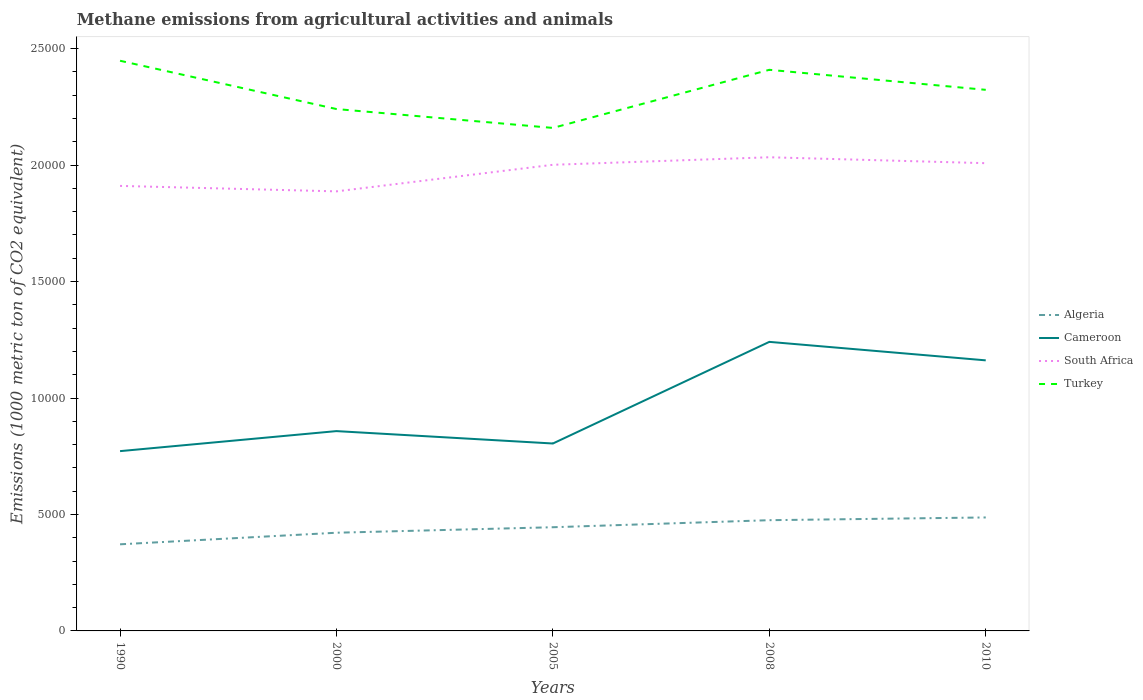Across all years, what is the maximum amount of methane emitted in Cameroon?
Provide a succinct answer. 7719.8. What is the total amount of methane emitted in Algeria in the graph?
Make the answer very short. -302.6. What is the difference between the highest and the second highest amount of methane emitted in Cameroon?
Provide a short and direct response. 4691.5. What is the difference between the highest and the lowest amount of methane emitted in Cameroon?
Offer a very short reply. 2. What is the difference between two consecutive major ticks on the Y-axis?
Give a very brief answer. 5000. Are the values on the major ticks of Y-axis written in scientific E-notation?
Offer a very short reply. No. Does the graph contain grids?
Provide a short and direct response. No. Where does the legend appear in the graph?
Offer a very short reply. Center right. How are the legend labels stacked?
Give a very brief answer. Vertical. What is the title of the graph?
Give a very brief answer. Methane emissions from agricultural activities and animals. Does "Djibouti" appear as one of the legend labels in the graph?
Your answer should be compact. No. What is the label or title of the Y-axis?
Make the answer very short. Emissions (1000 metric ton of CO2 equivalent). What is the Emissions (1000 metric ton of CO2 equivalent) in Algeria in 1990?
Offer a very short reply. 3718.9. What is the Emissions (1000 metric ton of CO2 equivalent) of Cameroon in 1990?
Provide a succinct answer. 7719.8. What is the Emissions (1000 metric ton of CO2 equivalent) in South Africa in 1990?
Provide a short and direct response. 1.91e+04. What is the Emissions (1000 metric ton of CO2 equivalent) in Turkey in 1990?
Your answer should be very brief. 2.45e+04. What is the Emissions (1000 metric ton of CO2 equivalent) in Algeria in 2000?
Ensure brevity in your answer.  4216.3. What is the Emissions (1000 metric ton of CO2 equivalent) of Cameroon in 2000?
Make the answer very short. 8579.6. What is the Emissions (1000 metric ton of CO2 equivalent) in South Africa in 2000?
Provide a succinct answer. 1.89e+04. What is the Emissions (1000 metric ton of CO2 equivalent) of Turkey in 2000?
Make the answer very short. 2.24e+04. What is the Emissions (1000 metric ton of CO2 equivalent) of Algeria in 2005?
Your answer should be very brief. 4452.1. What is the Emissions (1000 metric ton of CO2 equivalent) of Cameroon in 2005?
Provide a succinct answer. 8047.3. What is the Emissions (1000 metric ton of CO2 equivalent) of South Africa in 2005?
Your answer should be very brief. 2.00e+04. What is the Emissions (1000 metric ton of CO2 equivalent) of Turkey in 2005?
Your answer should be very brief. 2.16e+04. What is the Emissions (1000 metric ton of CO2 equivalent) in Algeria in 2008?
Keep it short and to the point. 4754.7. What is the Emissions (1000 metric ton of CO2 equivalent) of Cameroon in 2008?
Your answer should be compact. 1.24e+04. What is the Emissions (1000 metric ton of CO2 equivalent) of South Africa in 2008?
Offer a very short reply. 2.03e+04. What is the Emissions (1000 metric ton of CO2 equivalent) in Turkey in 2008?
Ensure brevity in your answer.  2.41e+04. What is the Emissions (1000 metric ton of CO2 equivalent) of Algeria in 2010?
Keep it short and to the point. 4872.2. What is the Emissions (1000 metric ton of CO2 equivalent) in Cameroon in 2010?
Provide a succinct answer. 1.16e+04. What is the Emissions (1000 metric ton of CO2 equivalent) of South Africa in 2010?
Ensure brevity in your answer.  2.01e+04. What is the Emissions (1000 metric ton of CO2 equivalent) in Turkey in 2010?
Give a very brief answer. 2.32e+04. Across all years, what is the maximum Emissions (1000 metric ton of CO2 equivalent) of Algeria?
Your answer should be very brief. 4872.2. Across all years, what is the maximum Emissions (1000 metric ton of CO2 equivalent) in Cameroon?
Ensure brevity in your answer.  1.24e+04. Across all years, what is the maximum Emissions (1000 metric ton of CO2 equivalent) in South Africa?
Ensure brevity in your answer.  2.03e+04. Across all years, what is the maximum Emissions (1000 metric ton of CO2 equivalent) in Turkey?
Your answer should be very brief. 2.45e+04. Across all years, what is the minimum Emissions (1000 metric ton of CO2 equivalent) of Algeria?
Ensure brevity in your answer.  3718.9. Across all years, what is the minimum Emissions (1000 metric ton of CO2 equivalent) of Cameroon?
Your answer should be compact. 7719.8. Across all years, what is the minimum Emissions (1000 metric ton of CO2 equivalent) in South Africa?
Make the answer very short. 1.89e+04. Across all years, what is the minimum Emissions (1000 metric ton of CO2 equivalent) in Turkey?
Your answer should be very brief. 2.16e+04. What is the total Emissions (1000 metric ton of CO2 equivalent) of Algeria in the graph?
Provide a short and direct response. 2.20e+04. What is the total Emissions (1000 metric ton of CO2 equivalent) of Cameroon in the graph?
Provide a succinct answer. 4.84e+04. What is the total Emissions (1000 metric ton of CO2 equivalent) in South Africa in the graph?
Provide a succinct answer. 9.84e+04. What is the total Emissions (1000 metric ton of CO2 equivalent) of Turkey in the graph?
Offer a very short reply. 1.16e+05. What is the difference between the Emissions (1000 metric ton of CO2 equivalent) in Algeria in 1990 and that in 2000?
Your answer should be very brief. -497.4. What is the difference between the Emissions (1000 metric ton of CO2 equivalent) in Cameroon in 1990 and that in 2000?
Provide a short and direct response. -859.8. What is the difference between the Emissions (1000 metric ton of CO2 equivalent) in South Africa in 1990 and that in 2000?
Make the answer very short. 234.6. What is the difference between the Emissions (1000 metric ton of CO2 equivalent) of Turkey in 1990 and that in 2000?
Your answer should be compact. 2073.6. What is the difference between the Emissions (1000 metric ton of CO2 equivalent) of Algeria in 1990 and that in 2005?
Provide a succinct answer. -733.2. What is the difference between the Emissions (1000 metric ton of CO2 equivalent) in Cameroon in 1990 and that in 2005?
Provide a succinct answer. -327.5. What is the difference between the Emissions (1000 metric ton of CO2 equivalent) in South Africa in 1990 and that in 2005?
Keep it short and to the point. -906.3. What is the difference between the Emissions (1000 metric ton of CO2 equivalent) of Turkey in 1990 and that in 2005?
Keep it short and to the point. 2884.1. What is the difference between the Emissions (1000 metric ton of CO2 equivalent) in Algeria in 1990 and that in 2008?
Your response must be concise. -1035.8. What is the difference between the Emissions (1000 metric ton of CO2 equivalent) in Cameroon in 1990 and that in 2008?
Make the answer very short. -4691.5. What is the difference between the Emissions (1000 metric ton of CO2 equivalent) in South Africa in 1990 and that in 2008?
Your answer should be very brief. -1229.7. What is the difference between the Emissions (1000 metric ton of CO2 equivalent) in Turkey in 1990 and that in 2008?
Your answer should be compact. 388.8. What is the difference between the Emissions (1000 metric ton of CO2 equivalent) in Algeria in 1990 and that in 2010?
Offer a very short reply. -1153.3. What is the difference between the Emissions (1000 metric ton of CO2 equivalent) in Cameroon in 1990 and that in 2010?
Offer a very short reply. -3897.7. What is the difference between the Emissions (1000 metric ton of CO2 equivalent) in South Africa in 1990 and that in 2010?
Keep it short and to the point. -975.4. What is the difference between the Emissions (1000 metric ton of CO2 equivalent) of Turkey in 1990 and that in 2010?
Make the answer very short. 1248.6. What is the difference between the Emissions (1000 metric ton of CO2 equivalent) of Algeria in 2000 and that in 2005?
Offer a very short reply. -235.8. What is the difference between the Emissions (1000 metric ton of CO2 equivalent) in Cameroon in 2000 and that in 2005?
Provide a succinct answer. 532.3. What is the difference between the Emissions (1000 metric ton of CO2 equivalent) of South Africa in 2000 and that in 2005?
Provide a short and direct response. -1140.9. What is the difference between the Emissions (1000 metric ton of CO2 equivalent) in Turkey in 2000 and that in 2005?
Your answer should be compact. 810.5. What is the difference between the Emissions (1000 metric ton of CO2 equivalent) in Algeria in 2000 and that in 2008?
Your answer should be compact. -538.4. What is the difference between the Emissions (1000 metric ton of CO2 equivalent) in Cameroon in 2000 and that in 2008?
Make the answer very short. -3831.7. What is the difference between the Emissions (1000 metric ton of CO2 equivalent) of South Africa in 2000 and that in 2008?
Provide a short and direct response. -1464.3. What is the difference between the Emissions (1000 metric ton of CO2 equivalent) in Turkey in 2000 and that in 2008?
Keep it short and to the point. -1684.8. What is the difference between the Emissions (1000 metric ton of CO2 equivalent) of Algeria in 2000 and that in 2010?
Your answer should be compact. -655.9. What is the difference between the Emissions (1000 metric ton of CO2 equivalent) of Cameroon in 2000 and that in 2010?
Your answer should be very brief. -3037.9. What is the difference between the Emissions (1000 metric ton of CO2 equivalent) of South Africa in 2000 and that in 2010?
Offer a terse response. -1210. What is the difference between the Emissions (1000 metric ton of CO2 equivalent) of Turkey in 2000 and that in 2010?
Provide a short and direct response. -825. What is the difference between the Emissions (1000 metric ton of CO2 equivalent) in Algeria in 2005 and that in 2008?
Ensure brevity in your answer.  -302.6. What is the difference between the Emissions (1000 metric ton of CO2 equivalent) in Cameroon in 2005 and that in 2008?
Your response must be concise. -4364. What is the difference between the Emissions (1000 metric ton of CO2 equivalent) of South Africa in 2005 and that in 2008?
Your answer should be compact. -323.4. What is the difference between the Emissions (1000 metric ton of CO2 equivalent) of Turkey in 2005 and that in 2008?
Your response must be concise. -2495.3. What is the difference between the Emissions (1000 metric ton of CO2 equivalent) of Algeria in 2005 and that in 2010?
Your answer should be very brief. -420.1. What is the difference between the Emissions (1000 metric ton of CO2 equivalent) in Cameroon in 2005 and that in 2010?
Make the answer very short. -3570.2. What is the difference between the Emissions (1000 metric ton of CO2 equivalent) of South Africa in 2005 and that in 2010?
Give a very brief answer. -69.1. What is the difference between the Emissions (1000 metric ton of CO2 equivalent) of Turkey in 2005 and that in 2010?
Offer a very short reply. -1635.5. What is the difference between the Emissions (1000 metric ton of CO2 equivalent) of Algeria in 2008 and that in 2010?
Make the answer very short. -117.5. What is the difference between the Emissions (1000 metric ton of CO2 equivalent) in Cameroon in 2008 and that in 2010?
Your response must be concise. 793.8. What is the difference between the Emissions (1000 metric ton of CO2 equivalent) in South Africa in 2008 and that in 2010?
Give a very brief answer. 254.3. What is the difference between the Emissions (1000 metric ton of CO2 equivalent) of Turkey in 2008 and that in 2010?
Give a very brief answer. 859.8. What is the difference between the Emissions (1000 metric ton of CO2 equivalent) in Algeria in 1990 and the Emissions (1000 metric ton of CO2 equivalent) in Cameroon in 2000?
Provide a succinct answer. -4860.7. What is the difference between the Emissions (1000 metric ton of CO2 equivalent) in Algeria in 1990 and the Emissions (1000 metric ton of CO2 equivalent) in South Africa in 2000?
Provide a short and direct response. -1.52e+04. What is the difference between the Emissions (1000 metric ton of CO2 equivalent) of Algeria in 1990 and the Emissions (1000 metric ton of CO2 equivalent) of Turkey in 2000?
Your answer should be compact. -1.87e+04. What is the difference between the Emissions (1000 metric ton of CO2 equivalent) of Cameroon in 1990 and the Emissions (1000 metric ton of CO2 equivalent) of South Africa in 2000?
Offer a very short reply. -1.12e+04. What is the difference between the Emissions (1000 metric ton of CO2 equivalent) of Cameroon in 1990 and the Emissions (1000 metric ton of CO2 equivalent) of Turkey in 2000?
Ensure brevity in your answer.  -1.47e+04. What is the difference between the Emissions (1000 metric ton of CO2 equivalent) of South Africa in 1990 and the Emissions (1000 metric ton of CO2 equivalent) of Turkey in 2000?
Keep it short and to the point. -3299.8. What is the difference between the Emissions (1000 metric ton of CO2 equivalent) of Algeria in 1990 and the Emissions (1000 metric ton of CO2 equivalent) of Cameroon in 2005?
Make the answer very short. -4328.4. What is the difference between the Emissions (1000 metric ton of CO2 equivalent) in Algeria in 1990 and the Emissions (1000 metric ton of CO2 equivalent) in South Africa in 2005?
Offer a very short reply. -1.63e+04. What is the difference between the Emissions (1000 metric ton of CO2 equivalent) of Algeria in 1990 and the Emissions (1000 metric ton of CO2 equivalent) of Turkey in 2005?
Your response must be concise. -1.79e+04. What is the difference between the Emissions (1000 metric ton of CO2 equivalent) in Cameroon in 1990 and the Emissions (1000 metric ton of CO2 equivalent) in South Africa in 2005?
Keep it short and to the point. -1.23e+04. What is the difference between the Emissions (1000 metric ton of CO2 equivalent) of Cameroon in 1990 and the Emissions (1000 metric ton of CO2 equivalent) of Turkey in 2005?
Make the answer very short. -1.39e+04. What is the difference between the Emissions (1000 metric ton of CO2 equivalent) in South Africa in 1990 and the Emissions (1000 metric ton of CO2 equivalent) in Turkey in 2005?
Offer a terse response. -2489.3. What is the difference between the Emissions (1000 metric ton of CO2 equivalent) in Algeria in 1990 and the Emissions (1000 metric ton of CO2 equivalent) in Cameroon in 2008?
Your answer should be very brief. -8692.4. What is the difference between the Emissions (1000 metric ton of CO2 equivalent) of Algeria in 1990 and the Emissions (1000 metric ton of CO2 equivalent) of South Africa in 2008?
Offer a terse response. -1.66e+04. What is the difference between the Emissions (1000 metric ton of CO2 equivalent) in Algeria in 1990 and the Emissions (1000 metric ton of CO2 equivalent) in Turkey in 2008?
Give a very brief answer. -2.04e+04. What is the difference between the Emissions (1000 metric ton of CO2 equivalent) of Cameroon in 1990 and the Emissions (1000 metric ton of CO2 equivalent) of South Africa in 2008?
Keep it short and to the point. -1.26e+04. What is the difference between the Emissions (1000 metric ton of CO2 equivalent) of Cameroon in 1990 and the Emissions (1000 metric ton of CO2 equivalent) of Turkey in 2008?
Keep it short and to the point. -1.64e+04. What is the difference between the Emissions (1000 metric ton of CO2 equivalent) in South Africa in 1990 and the Emissions (1000 metric ton of CO2 equivalent) in Turkey in 2008?
Your answer should be very brief. -4984.6. What is the difference between the Emissions (1000 metric ton of CO2 equivalent) in Algeria in 1990 and the Emissions (1000 metric ton of CO2 equivalent) in Cameroon in 2010?
Give a very brief answer. -7898.6. What is the difference between the Emissions (1000 metric ton of CO2 equivalent) of Algeria in 1990 and the Emissions (1000 metric ton of CO2 equivalent) of South Africa in 2010?
Offer a very short reply. -1.64e+04. What is the difference between the Emissions (1000 metric ton of CO2 equivalent) in Algeria in 1990 and the Emissions (1000 metric ton of CO2 equivalent) in Turkey in 2010?
Ensure brevity in your answer.  -1.95e+04. What is the difference between the Emissions (1000 metric ton of CO2 equivalent) of Cameroon in 1990 and the Emissions (1000 metric ton of CO2 equivalent) of South Africa in 2010?
Offer a terse response. -1.24e+04. What is the difference between the Emissions (1000 metric ton of CO2 equivalent) of Cameroon in 1990 and the Emissions (1000 metric ton of CO2 equivalent) of Turkey in 2010?
Make the answer very short. -1.55e+04. What is the difference between the Emissions (1000 metric ton of CO2 equivalent) of South Africa in 1990 and the Emissions (1000 metric ton of CO2 equivalent) of Turkey in 2010?
Offer a very short reply. -4124.8. What is the difference between the Emissions (1000 metric ton of CO2 equivalent) in Algeria in 2000 and the Emissions (1000 metric ton of CO2 equivalent) in Cameroon in 2005?
Ensure brevity in your answer.  -3831. What is the difference between the Emissions (1000 metric ton of CO2 equivalent) of Algeria in 2000 and the Emissions (1000 metric ton of CO2 equivalent) of South Africa in 2005?
Provide a short and direct response. -1.58e+04. What is the difference between the Emissions (1000 metric ton of CO2 equivalent) in Algeria in 2000 and the Emissions (1000 metric ton of CO2 equivalent) in Turkey in 2005?
Ensure brevity in your answer.  -1.74e+04. What is the difference between the Emissions (1000 metric ton of CO2 equivalent) of Cameroon in 2000 and the Emissions (1000 metric ton of CO2 equivalent) of South Africa in 2005?
Your answer should be compact. -1.14e+04. What is the difference between the Emissions (1000 metric ton of CO2 equivalent) of Cameroon in 2000 and the Emissions (1000 metric ton of CO2 equivalent) of Turkey in 2005?
Provide a short and direct response. -1.30e+04. What is the difference between the Emissions (1000 metric ton of CO2 equivalent) in South Africa in 2000 and the Emissions (1000 metric ton of CO2 equivalent) in Turkey in 2005?
Ensure brevity in your answer.  -2723.9. What is the difference between the Emissions (1000 metric ton of CO2 equivalent) in Algeria in 2000 and the Emissions (1000 metric ton of CO2 equivalent) in Cameroon in 2008?
Keep it short and to the point. -8195. What is the difference between the Emissions (1000 metric ton of CO2 equivalent) in Algeria in 2000 and the Emissions (1000 metric ton of CO2 equivalent) in South Africa in 2008?
Provide a short and direct response. -1.61e+04. What is the difference between the Emissions (1000 metric ton of CO2 equivalent) of Algeria in 2000 and the Emissions (1000 metric ton of CO2 equivalent) of Turkey in 2008?
Give a very brief answer. -1.99e+04. What is the difference between the Emissions (1000 metric ton of CO2 equivalent) of Cameroon in 2000 and the Emissions (1000 metric ton of CO2 equivalent) of South Africa in 2008?
Your answer should be very brief. -1.18e+04. What is the difference between the Emissions (1000 metric ton of CO2 equivalent) of Cameroon in 2000 and the Emissions (1000 metric ton of CO2 equivalent) of Turkey in 2008?
Provide a succinct answer. -1.55e+04. What is the difference between the Emissions (1000 metric ton of CO2 equivalent) in South Africa in 2000 and the Emissions (1000 metric ton of CO2 equivalent) in Turkey in 2008?
Offer a terse response. -5219.2. What is the difference between the Emissions (1000 metric ton of CO2 equivalent) in Algeria in 2000 and the Emissions (1000 metric ton of CO2 equivalent) in Cameroon in 2010?
Your answer should be very brief. -7401.2. What is the difference between the Emissions (1000 metric ton of CO2 equivalent) in Algeria in 2000 and the Emissions (1000 metric ton of CO2 equivalent) in South Africa in 2010?
Your answer should be compact. -1.59e+04. What is the difference between the Emissions (1000 metric ton of CO2 equivalent) of Algeria in 2000 and the Emissions (1000 metric ton of CO2 equivalent) of Turkey in 2010?
Ensure brevity in your answer.  -1.90e+04. What is the difference between the Emissions (1000 metric ton of CO2 equivalent) of Cameroon in 2000 and the Emissions (1000 metric ton of CO2 equivalent) of South Africa in 2010?
Keep it short and to the point. -1.15e+04. What is the difference between the Emissions (1000 metric ton of CO2 equivalent) in Cameroon in 2000 and the Emissions (1000 metric ton of CO2 equivalent) in Turkey in 2010?
Give a very brief answer. -1.47e+04. What is the difference between the Emissions (1000 metric ton of CO2 equivalent) in South Africa in 2000 and the Emissions (1000 metric ton of CO2 equivalent) in Turkey in 2010?
Offer a very short reply. -4359.4. What is the difference between the Emissions (1000 metric ton of CO2 equivalent) of Algeria in 2005 and the Emissions (1000 metric ton of CO2 equivalent) of Cameroon in 2008?
Offer a terse response. -7959.2. What is the difference between the Emissions (1000 metric ton of CO2 equivalent) in Algeria in 2005 and the Emissions (1000 metric ton of CO2 equivalent) in South Africa in 2008?
Offer a very short reply. -1.59e+04. What is the difference between the Emissions (1000 metric ton of CO2 equivalent) in Algeria in 2005 and the Emissions (1000 metric ton of CO2 equivalent) in Turkey in 2008?
Your answer should be compact. -1.96e+04. What is the difference between the Emissions (1000 metric ton of CO2 equivalent) of Cameroon in 2005 and the Emissions (1000 metric ton of CO2 equivalent) of South Africa in 2008?
Your answer should be very brief. -1.23e+04. What is the difference between the Emissions (1000 metric ton of CO2 equivalent) of Cameroon in 2005 and the Emissions (1000 metric ton of CO2 equivalent) of Turkey in 2008?
Ensure brevity in your answer.  -1.60e+04. What is the difference between the Emissions (1000 metric ton of CO2 equivalent) of South Africa in 2005 and the Emissions (1000 metric ton of CO2 equivalent) of Turkey in 2008?
Provide a succinct answer. -4078.3. What is the difference between the Emissions (1000 metric ton of CO2 equivalent) of Algeria in 2005 and the Emissions (1000 metric ton of CO2 equivalent) of Cameroon in 2010?
Provide a succinct answer. -7165.4. What is the difference between the Emissions (1000 metric ton of CO2 equivalent) of Algeria in 2005 and the Emissions (1000 metric ton of CO2 equivalent) of South Africa in 2010?
Your answer should be very brief. -1.56e+04. What is the difference between the Emissions (1000 metric ton of CO2 equivalent) of Algeria in 2005 and the Emissions (1000 metric ton of CO2 equivalent) of Turkey in 2010?
Offer a terse response. -1.88e+04. What is the difference between the Emissions (1000 metric ton of CO2 equivalent) of Cameroon in 2005 and the Emissions (1000 metric ton of CO2 equivalent) of South Africa in 2010?
Your response must be concise. -1.20e+04. What is the difference between the Emissions (1000 metric ton of CO2 equivalent) in Cameroon in 2005 and the Emissions (1000 metric ton of CO2 equivalent) in Turkey in 2010?
Provide a short and direct response. -1.52e+04. What is the difference between the Emissions (1000 metric ton of CO2 equivalent) of South Africa in 2005 and the Emissions (1000 metric ton of CO2 equivalent) of Turkey in 2010?
Provide a succinct answer. -3218.5. What is the difference between the Emissions (1000 metric ton of CO2 equivalent) in Algeria in 2008 and the Emissions (1000 metric ton of CO2 equivalent) in Cameroon in 2010?
Your answer should be very brief. -6862.8. What is the difference between the Emissions (1000 metric ton of CO2 equivalent) in Algeria in 2008 and the Emissions (1000 metric ton of CO2 equivalent) in South Africa in 2010?
Provide a succinct answer. -1.53e+04. What is the difference between the Emissions (1000 metric ton of CO2 equivalent) in Algeria in 2008 and the Emissions (1000 metric ton of CO2 equivalent) in Turkey in 2010?
Your response must be concise. -1.85e+04. What is the difference between the Emissions (1000 metric ton of CO2 equivalent) of Cameroon in 2008 and the Emissions (1000 metric ton of CO2 equivalent) of South Africa in 2010?
Your response must be concise. -7672.3. What is the difference between the Emissions (1000 metric ton of CO2 equivalent) of Cameroon in 2008 and the Emissions (1000 metric ton of CO2 equivalent) of Turkey in 2010?
Your answer should be very brief. -1.08e+04. What is the difference between the Emissions (1000 metric ton of CO2 equivalent) in South Africa in 2008 and the Emissions (1000 metric ton of CO2 equivalent) in Turkey in 2010?
Ensure brevity in your answer.  -2895.1. What is the average Emissions (1000 metric ton of CO2 equivalent) in Algeria per year?
Give a very brief answer. 4402.84. What is the average Emissions (1000 metric ton of CO2 equivalent) of Cameroon per year?
Provide a short and direct response. 9675.1. What is the average Emissions (1000 metric ton of CO2 equivalent) in South Africa per year?
Offer a very short reply. 1.97e+04. What is the average Emissions (1000 metric ton of CO2 equivalent) in Turkey per year?
Provide a short and direct response. 2.32e+04. In the year 1990, what is the difference between the Emissions (1000 metric ton of CO2 equivalent) of Algeria and Emissions (1000 metric ton of CO2 equivalent) of Cameroon?
Your answer should be very brief. -4000.9. In the year 1990, what is the difference between the Emissions (1000 metric ton of CO2 equivalent) of Algeria and Emissions (1000 metric ton of CO2 equivalent) of South Africa?
Your response must be concise. -1.54e+04. In the year 1990, what is the difference between the Emissions (1000 metric ton of CO2 equivalent) in Algeria and Emissions (1000 metric ton of CO2 equivalent) in Turkey?
Offer a terse response. -2.08e+04. In the year 1990, what is the difference between the Emissions (1000 metric ton of CO2 equivalent) of Cameroon and Emissions (1000 metric ton of CO2 equivalent) of South Africa?
Provide a short and direct response. -1.14e+04. In the year 1990, what is the difference between the Emissions (1000 metric ton of CO2 equivalent) of Cameroon and Emissions (1000 metric ton of CO2 equivalent) of Turkey?
Make the answer very short. -1.68e+04. In the year 1990, what is the difference between the Emissions (1000 metric ton of CO2 equivalent) in South Africa and Emissions (1000 metric ton of CO2 equivalent) in Turkey?
Your response must be concise. -5373.4. In the year 2000, what is the difference between the Emissions (1000 metric ton of CO2 equivalent) in Algeria and Emissions (1000 metric ton of CO2 equivalent) in Cameroon?
Give a very brief answer. -4363.3. In the year 2000, what is the difference between the Emissions (1000 metric ton of CO2 equivalent) in Algeria and Emissions (1000 metric ton of CO2 equivalent) in South Africa?
Offer a terse response. -1.47e+04. In the year 2000, what is the difference between the Emissions (1000 metric ton of CO2 equivalent) of Algeria and Emissions (1000 metric ton of CO2 equivalent) of Turkey?
Provide a short and direct response. -1.82e+04. In the year 2000, what is the difference between the Emissions (1000 metric ton of CO2 equivalent) of Cameroon and Emissions (1000 metric ton of CO2 equivalent) of South Africa?
Provide a short and direct response. -1.03e+04. In the year 2000, what is the difference between the Emissions (1000 metric ton of CO2 equivalent) in Cameroon and Emissions (1000 metric ton of CO2 equivalent) in Turkey?
Give a very brief answer. -1.38e+04. In the year 2000, what is the difference between the Emissions (1000 metric ton of CO2 equivalent) of South Africa and Emissions (1000 metric ton of CO2 equivalent) of Turkey?
Offer a terse response. -3534.4. In the year 2005, what is the difference between the Emissions (1000 metric ton of CO2 equivalent) in Algeria and Emissions (1000 metric ton of CO2 equivalent) in Cameroon?
Ensure brevity in your answer.  -3595.2. In the year 2005, what is the difference between the Emissions (1000 metric ton of CO2 equivalent) of Algeria and Emissions (1000 metric ton of CO2 equivalent) of South Africa?
Offer a very short reply. -1.56e+04. In the year 2005, what is the difference between the Emissions (1000 metric ton of CO2 equivalent) in Algeria and Emissions (1000 metric ton of CO2 equivalent) in Turkey?
Your response must be concise. -1.71e+04. In the year 2005, what is the difference between the Emissions (1000 metric ton of CO2 equivalent) in Cameroon and Emissions (1000 metric ton of CO2 equivalent) in South Africa?
Provide a succinct answer. -1.20e+04. In the year 2005, what is the difference between the Emissions (1000 metric ton of CO2 equivalent) in Cameroon and Emissions (1000 metric ton of CO2 equivalent) in Turkey?
Your response must be concise. -1.36e+04. In the year 2005, what is the difference between the Emissions (1000 metric ton of CO2 equivalent) in South Africa and Emissions (1000 metric ton of CO2 equivalent) in Turkey?
Provide a succinct answer. -1583. In the year 2008, what is the difference between the Emissions (1000 metric ton of CO2 equivalent) in Algeria and Emissions (1000 metric ton of CO2 equivalent) in Cameroon?
Ensure brevity in your answer.  -7656.6. In the year 2008, what is the difference between the Emissions (1000 metric ton of CO2 equivalent) of Algeria and Emissions (1000 metric ton of CO2 equivalent) of South Africa?
Your response must be concise. -1.56e+04. In the year 2008, what is the difference between the Emissions (1000 metric ton of CO2 equivalent) of Algeria and Emissions (1000 metric ton of CO2 equivalent) of Turkey?
Offer a very short reply. -1.93e+04. In the year 2008, what is the difference between the Emissions (1000 metric ton of CO2 equivalent) of Cameroon and Emissions (1000 metric ton of CO2 equivalent) of South Africa?
Your answer should be very brief. -7926.6. In the year 2008, what is the difference between the Emissions (1000 metric ton of CO2 equivalent) in Cameroon and Emissions (1000 metric ton of CO2 equivalent) in Turkey?
Offer a very short reply. -1.17e+04. In the year 2008, what is the difference between the Emissions (1000 metric ton of CO2 equivalent) in South Africa and Emissions (1000 metric ton of CO2 equivalent) in Turkey?
Keep it short and to the point. -3754.9. In the year 2010, what is the difference between the Emissions (1000 metric ton of CO2 equivalent) of Algeria and Emissions (1000 metric ton of CO2 equivalent) of Cameroon?
Ensure brevity in your answer.  -6745.3. In the year 2010, what is the difference between the Emissions (1000 metric ton of CO2 equivalent) of Algeria and Emissions (1000 metric ton of CO2 equivalent) of South Africa?
Your response must be concise. -1.52e+04. In the year 2010, what is the difference between the Emissions (1000 metric ton of CO2 equivalent) of Algeria and Emissions (1000 metric ton of CO2 equivalent) of Turkey?
Your response must be concise. -1.84e+04. In the year 2010, what is the difference between the Emissions (1000 metric ton of CO2 equivalent) in Cameroon and Emissions (1000 metric ton of CO2 equivalent) in South Africa?
Your answer should be compact. -8466.1. In the year 2010, what is the difference between the Emissions (1000 metric ton of CO2 equivalent) of Cameroon and Emissions (1000 metric ton of CO2 equivalent) of Turkey?
Ensure brevity in your answer.  -1.16e+04. In the year 2010, what is the difference between the Emissions (1000 metric ton of CO2 equivalent) of South Africa and Emissions (1000 metric ton of CO2 equivalent) of Turkey?
Give a very brief answer. -3149.4. What is the ratio of the Emissions (1000 metric ton of CO2 equivalent) of Algeria in 1990 to that in 2000?
Your answer should be compact. 0.88. What is the ratio of the Emissions (1000 metric ton of CO2 equivalent) in Cameroon in 1990 to that in 2000?
Give a very brief answer. 0.9. What is the ratio of the Emissions (1000 metric ton of CO2 equivalent) in South Africa in 1990 to that in 2000?
Your answer should be very brief. 1.01. What is the ratio of the Emissions (1000 metric ton of CO2 equivalent) of Turkey in 1990 to that in 2000?
Your answer should be very brief. 1.09. What is the ratio of the Emissions (1000 metric ton of CO2 equivalent) of Algeria in 1990 to that in 2005?
Provide a short and direct response. 0.84. What is the ratio of the Emissions (1000 metric ton of CO2 equivalent) of Cameroon in 1990 to that in 2005?
Your answer should be very brief. 0.96. What is the ratio of the Emissions (1000 metric ton of CO2 equivalent) of South Africa in 1990 to that in 2005?
Make the answer very short. 0.95. What is the ratio of the Emissions (1000 metric ton of CO2 equivalent) in Turkey in 1990 to that in 2005?
Provide a short and direct response. 1.13. What is the ratio of the Emissions (1000 metric ton of CO2 equivalent) of Algeria in 1990 to that in 2008?
Give a very brief answer. 0.78. What is the ratio of the Emissions (1000 metric ton of CO2 equivalent) of Cameroon in 1990 to that in 2008?
Your response must be concise. 0.62. What is the ratio of the Emissions (1000 metric ton of CO2 equivalent) of South Africa in 1990 to that in 2008?
Your response must be concise. 0.94. What is the ratio of the Emissions (1000 metric ton of CO2 equivalent) of Turkey in 1990 to that in 2008?
Give a very brief answer. 1.02. What is the ratio of the Emissions (1000 metric ton of CO2 equivalent) of Algeria in 1990 to that in 2010?
Offer a terse response. 0.76. What is the ratio of the Emissions (1000 metric ton of CO2 equivalent) in Cameroon in 1990 to that in 2010?
Keep it short and to the point. 0.66. What is the ratio of the Emissions (1000 metric ton of CO2 equivalent) of South Africa in 1990 to that in 2010?
Your answer should be very brief. 0.95. What is the ratio of the Emissions (1000 metric ton of CO2 equivalent) in Turkey in 1990 to that in 2010?
Give a very brief answer. 1.05. What is the ratio of the Emissions (1000 metric ton of CO2 equivalent) in Algeria in 2000 to that in 2005?
Your answer should be very brief. 0.95. What is the ratio of the Emissions (1000 metric ton of CO2 equivalent) of Cameroon in 2000 to that in 2005?
Your answer should be compact. 1.07. What is the ratio of the Emissions (1000 metric ton of CO2 equivalent) of South Africa in 2000 to that in 2005?
Ensure brevity in your answer.  0.94. What is the ratio of the Emissions (1000 metric ton of CO2 equivalent) in Turkey in 2000 to that in 2005?
Your response must be concise. 1.04. What is the ratio of the Emissions (1000 metric ton of CO2 equivalent) in Algeria in 2000 to that in 2008?
Ensure brevity in your answer.  0.89. What is the ratio of the Emissions (1000 metric ton of CO2 equivalent) in Cameroon in 2000 to that in 2008?
Keep it short and to the point. 0.69. What is the ratio of the Emissions (1000 metric ton of CO2 equivalent) in South Africa in 2000 to that in 2008?
Your answer should be very brief. 0.93. What is the ratio of the Emissions (1000 metric ton of CO2 equivalent) of Turkey in 2000 to that in 2008?
Offer a terse response. 0.93. What is the ratio of the Emissions (1000 metric ton of CO2 equivalent) of Algeria in 2000 to that in 2010?
Make the answer very short. 0.87. What is the ratio of the Emissions (1000 metric ton of CO2 equivalent) in Cameroon in 2000 to that in 2010?
Make the answer very short. 0.74. What is the ratio of the Emissions (1000 metric ton of CO2 equivalent) of South Africa in 2000 to that in 2010?
Make the answer very short. 0.94. What is the ratio of the Emissions (1000 metric ton of CO2 equivalent) in Turkey in 2000 to that in 2010?
Ensure brevity in your answer.  0.96. What is the ratio of the Emissions (1000 metric ton of CO2 equivalent) in Algeria in 2005 to that in 2008?
Provide a succinct answer. 0.94. What is the ratio of the Emissions (1000 metric ton of CO2 equivalent) of Cameroon in 2005 to that in 2008?
Ensure brevity in your answer.  0.65. What is the ratio of the Emissions (1000 metric ton of CO2 equivalent) of South Africa in 2005 to that in 2008?
Offer a terse response. 0.98. What is the ratio of the Emissions (1000 metric ton of CO2 equivalent) in Turkey in 2005 to that in 2008?
Offer a terse response. 0.9. What is the ratio of the Emissions (1000 metric ton of CO2 equivalent) in Algeria in 2005 to that in 2010?
Ensure brevity in your answer.  0.91. What is the ratio of the Emissions (1000 metric ton of CO2 equivalent) in Cameroon in 2005 to that in 2010?
Give a very brief answer. 0.69. What is the ratio of the Emissions (1000 metric ton of CO2 equivalent) of Turkey in 2005 to that in 2010?
Your response must be concise. 0.93. What is the ratio of the Emissions (1000 metric ton of CO2 equivalent) in Algeria in 2008 to that in 2010?
Make the answer very short. 0.98. What is the ratio of the Emissions (1000 metric ton of CO2 equivalent) in Cameroon in 2008 to that in 2010?
Offer a very short reply. 1.07. What is the ratio of the Emissions (1000 metric ton of CO2 equivalent) in South Africa in 2008 to that in 2010?
Your response must be concise. 1.01. What is the ratio of the Emissions (1000 metric ton of CO2 equivalent) of Turkey in 2008 to that in 2010?
Keep it short and to the point. 1.04. What is the difference between the highest and the second highest Emissions (1000 metric ton of CO2 equivalent) in Algeria?
Give a very brief answer. 117.5. What is the difference between the highest and the second highest Emissions (1000 metric ton of CO2 equivalent) in Cameroon?
Offer a very short reply. 793.8. What is the difference between the highest and the second highest Emissions (1000 metric ton of CO2 equivalent) in South Africa?
Your answer should be compact. 254.3. What is the difference between the highest and the second highest Emissions (1000 metric ton of CO2 equivalent) in Turkey?
Offer a very short reply. 388.8. What is the difference between the highest and the lowest Emissions (1000 metric ton of CO2 equivalent) of Algeria?
Give a very brief answer. 1153.3. What is the difference between the highest and the lowest Emissions (1000 metric ton of CO2 equivalent) in Cameroon?
Give a very brief answer. 4691.5. What is the difference between the highest and the lowest Emissions (1000 metric ton of CO2 equivalent) in South Africa?
Provide a succinct answer. 1464.3. What is the difference between the highest and the lowest Emissions (1000 metric ton of CO2 equivalent) in Turkey?
Ensure brevity in your answer.  2884.1. 